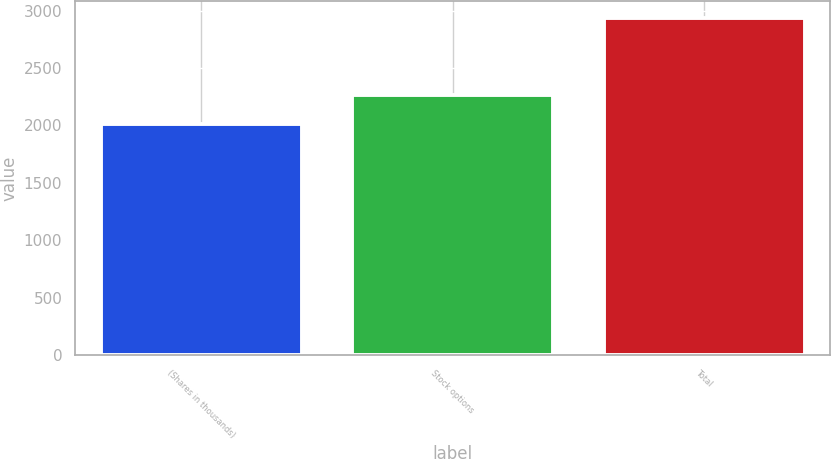Convert chart to OTSL. <chart><loc_0><loc_0><loc_500><loc_500><bar_chart><fcel>(Shares in thousands)<fcel>Stock options<fcel>Total<nl><fcel>2009<fcel>2267<fcel>2939<nl></chart> 